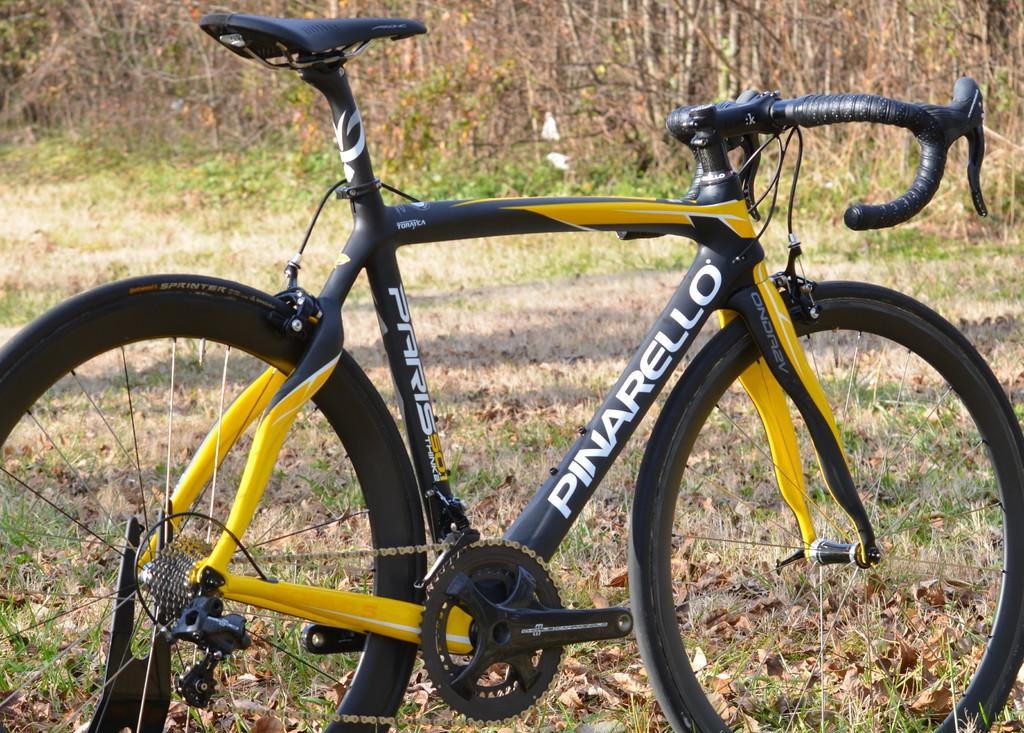What is the main object in the picture? There is a bicycle in the picture. What colors can be seen on the bicycle? The bicycle is black and yellow in color. What type of vegetation is visible in the picture? There are plants visible in the picture. What is the ground covered with in the picture? There is grass on the ground in the picture. How many beds can be seen in the picture? There are no beds present in the picture; it features a bicycle and plants. What type of pie is being served on the bicycle in the picture? There is no pie visible in the picture; it only shows a bicycle and plants. 